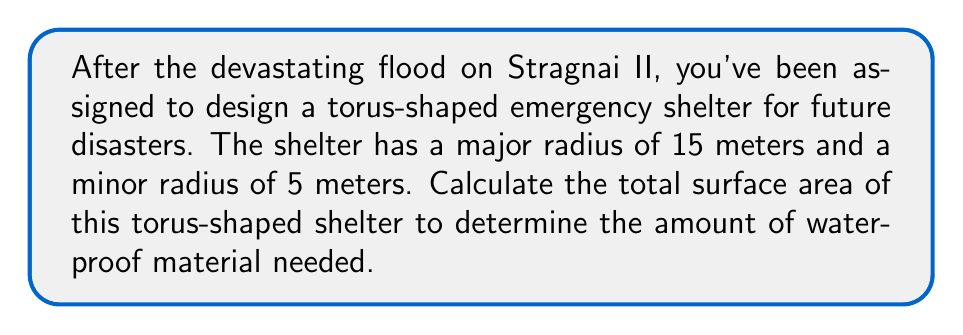Show me your answer to this math problem. To calculate the surface area of a torus, we need to use the formula:

$$A = 4\pi^2Rr$$

Where:
$A$ is the surface area
$R$ is the major radius (distance from the center of the tube to the center of the torus)
$r$ is the minor radius (radius of the tube)

Given:
$R = 15$ meters
$r = 5$ meters

Let's substitute these values into the formula:

$$\begin{align*}
A &= 4\pi^2Rr \\
&= 4\pi^2 \cdot 15 \cdot 5 \\
&= 4\pi^2 \cdot 75 \\
&= 300\pi^2
\end{align*}$$

Now, let's calculate this value:

$$\begin{align*}
A &= 300\pi^2 \\
&\approx 300 \cdot 9.8696 \\
&\approx 2960.88 \text{ square meters}
\end{align*}$$

[asy]
import geometry;

size(200);
currentprojection=perspective(6,3,2);

real R = 2;
real r = 0.5;

path3 p = circle(c = (R,0,0), r = r, normal = (0,0,1));
revolution torus = revolution(p, Z);
draw(surface(torus), paleblue+opacity(0.7));

draw(circle((0,0,0),R), dashed);
draw((R,0,0)--(R+r,0,0), arrow=Arrow3);
draw((0,0,0)--(R,0,0), arrow=Arrow3);

label("$r$", (R+r/2,0,0), E);
label("$R$", (R/2,0,0), S);
[/asy]
Answer: The surface area of the torus-shaped emergency shelter is approximately 2960.88 square meters. 